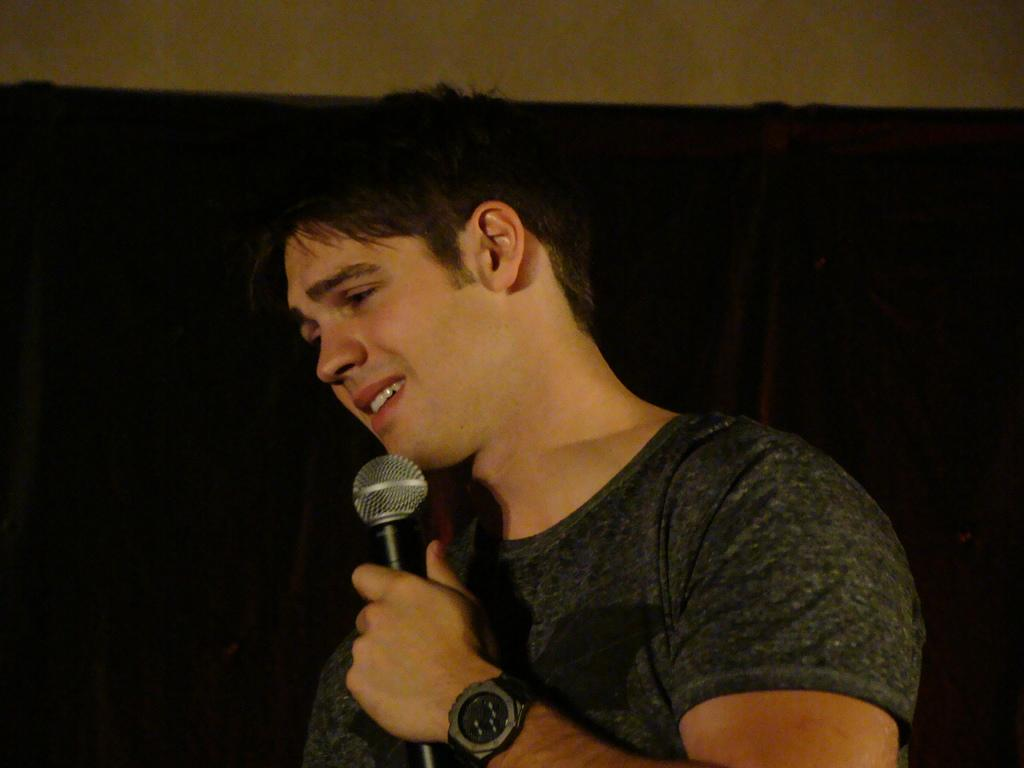What is the main subject of the image? There is a man in the image. What is the man holding in his left hand? The man is holding a microphone in his left hand. What is the man doing in the image? The man is speaking. What type of vein can be seen on the man's forehead in the image? There is no visible vein on the man's forehead in the image. How many drops of water are falling on the man's head in the image? There are no drops of water visible on the man's head in the image. 